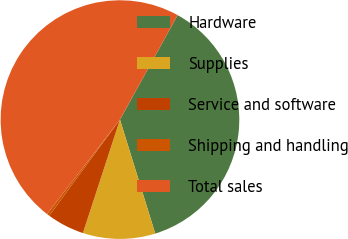Convert chart. <chart><loc_0><loc_0><loc_500><loc_500><pie_chart><fcel>Hardware<fcel>Supplies<fcel>Service and software<fcel>Shipping and handling<fcel>Total sales<nl><fcel>37.2%<fcel>9.8%<fcel>5.08%<fcel>0.36%<fcel>47.57%<nl></chart> 